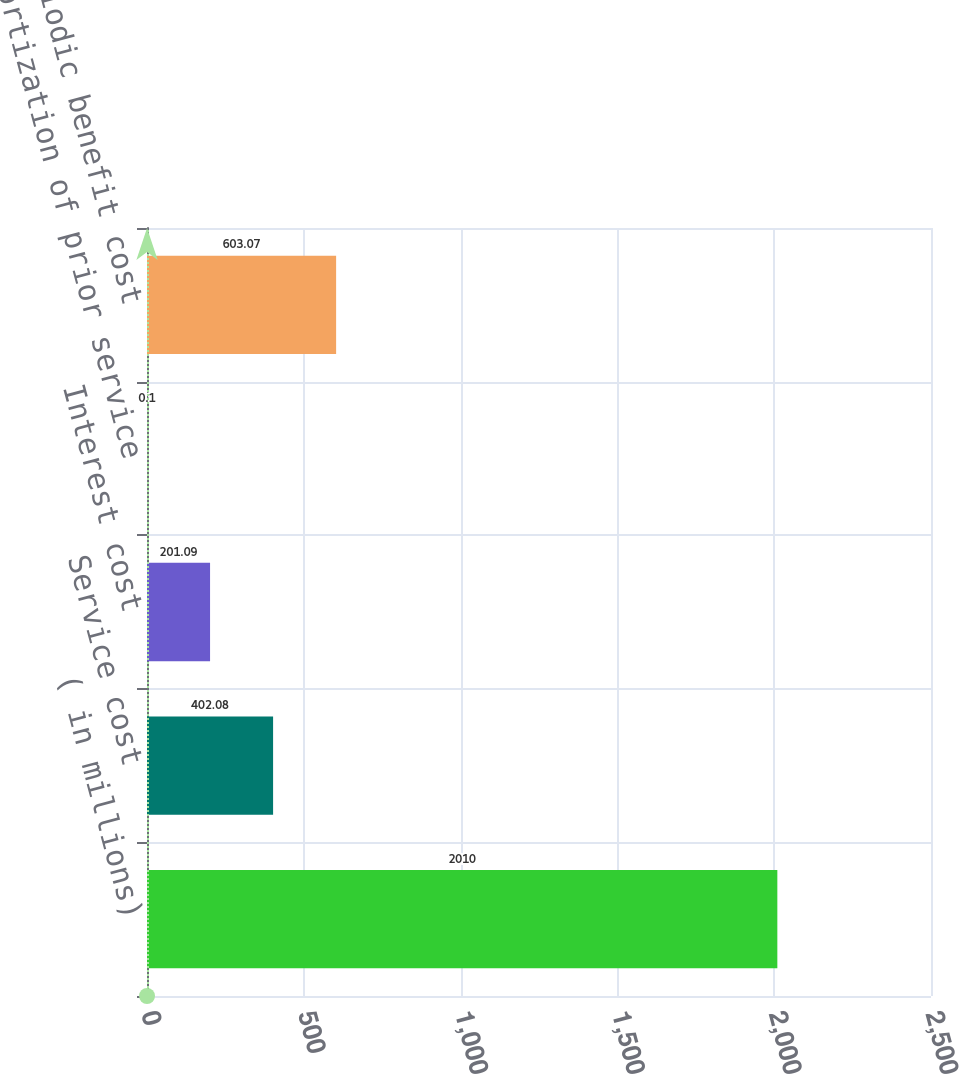<chart> <loc_0><loc_0><loc_500><loc_500><bar_chart><fcel>( in millions)<fcel>Service cost<fcel>Interest cost<fcel>Amortization of prior service<fcel>Net periodic benefit cost<nl><fcel>2010<fcel>402.08<fcel>201.09<fcel>0.1<fcel>603.07<nl></chart> 